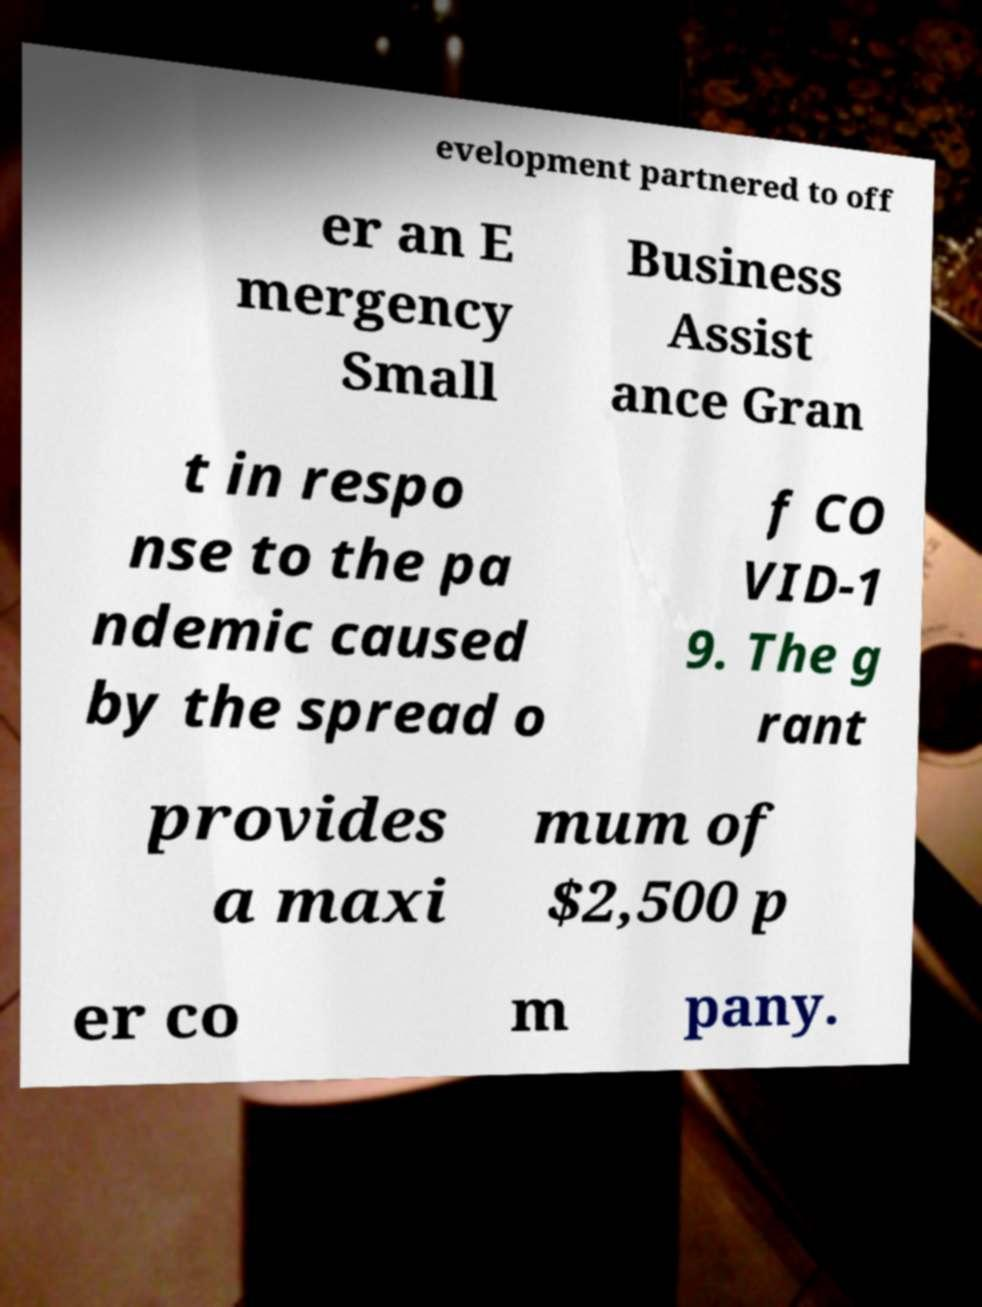There's text embedded in this image that I need extracted. Can you transcribe it verbatim? evelopment partnered to off er an E mergency Small Business Assist ance Gran t in respo nse to the pa ndemic caused by the spread o f CO VID-1 9. The g rant provides a maxi mum of $2,500 p er co m pany. 